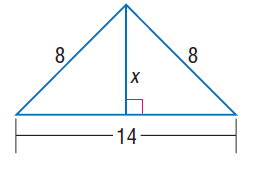Question: Find x.
Choices:
A. \sqrt { 15 }
B. 6
C. \sqrt { 83 }
D. 10
Answer with the letter. Answer: A 